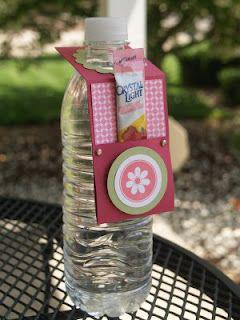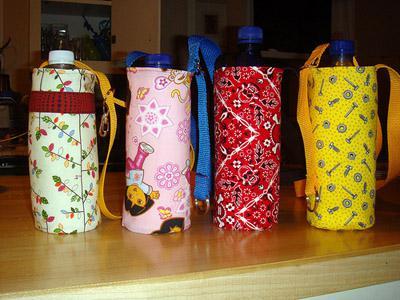The first image is the image on the left, the second image is the image on the right. Examine the images to the left and right. Is the description "In one of the images, four water bottles with carrying straps are sitting in a row on a table." accurate? Answer yes or no. Yes. The first image is the image on the left, the second image is the image on the right. For the images displayed, is the sentence "One image features a horizontal row of four water bottles with straps on them and different designs on their fronts." factually correct? Answer yes or no. Yes. 